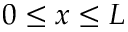<formula> <loc_0><loc_0><loc_500><loc_500>0 \leq x \leq L</formula> 